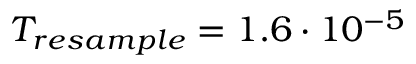Convert formula to latex. <formula><loc_0><loc_0><loc_500><loc_500>T _ { r e s a m p l e } = 1 . 6 \cdot 1 0 ^ { - 5 }</formula> 